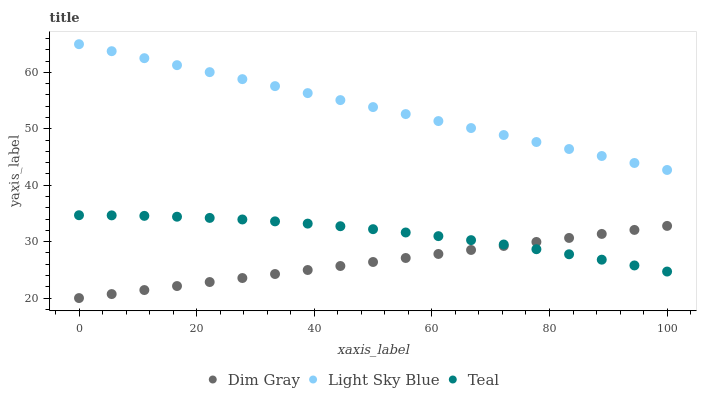Does Dim Gray have the minimum area under the curve?
Answer yes or no. Yes. Does Light Sky Blue have the maximum area under the curve?
Answer yes or no. Yes. Does Teal have the minimum area under the curve?
Answer yes or no. No. Does Teal have the maximum area under the curve?
Answer yes or no. No. Is Dim Gray the smoothest?
Answer yes or no. Yes. Is Teal the roughest?
Answer yes or no. Yes. Is Light Sky Blue the smoothest?
Answer yes or no. No. Is Light Sky Blue the roughest?
Answer yes or no. No. Does Dim Gray have the lowest value?
Answer yes or no. Yes. Does Teal have the lowest value?
Answer yes or no. No. Does Light Sky Blue have the highest value?
Answer yes or no. Yes. Does Teal have the highest value?
Answer yes or no. No. Is Teal less than Light Sky Blue?
Answer yes or no. Yes. Is Light Sky Blue greater than Teal?
Answer yes or no. Yes. Does Teal intersect Dim Gray?
Answer yes or no. Yes. Is Teal less than Dim Gray?
Answer yes or no. No. Is Teal greater than Dim Gray?
Answer yes or no. No. Does Teal intersect Light Sky Blue?
Answer yes or no. No. 